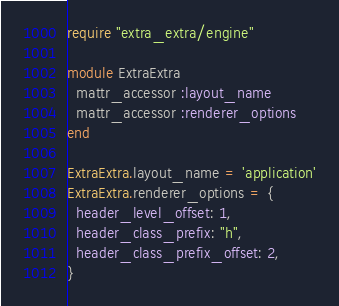<code> <loc_0><loc_0><loc_500><loc_500><_Ruby_>require "extra_extra/engine"

module ExtraExtra
  mattr_accessor :layout_name
  mattr_accessor :renderer_options
end

ExtraExtra.layout_name = 'application'
ExtraExtra.renderer_options = {
  header_level_offset: 1,
  header_class_prefix: "h",
  header_class_prefix_offset: 2,
}
</code> 